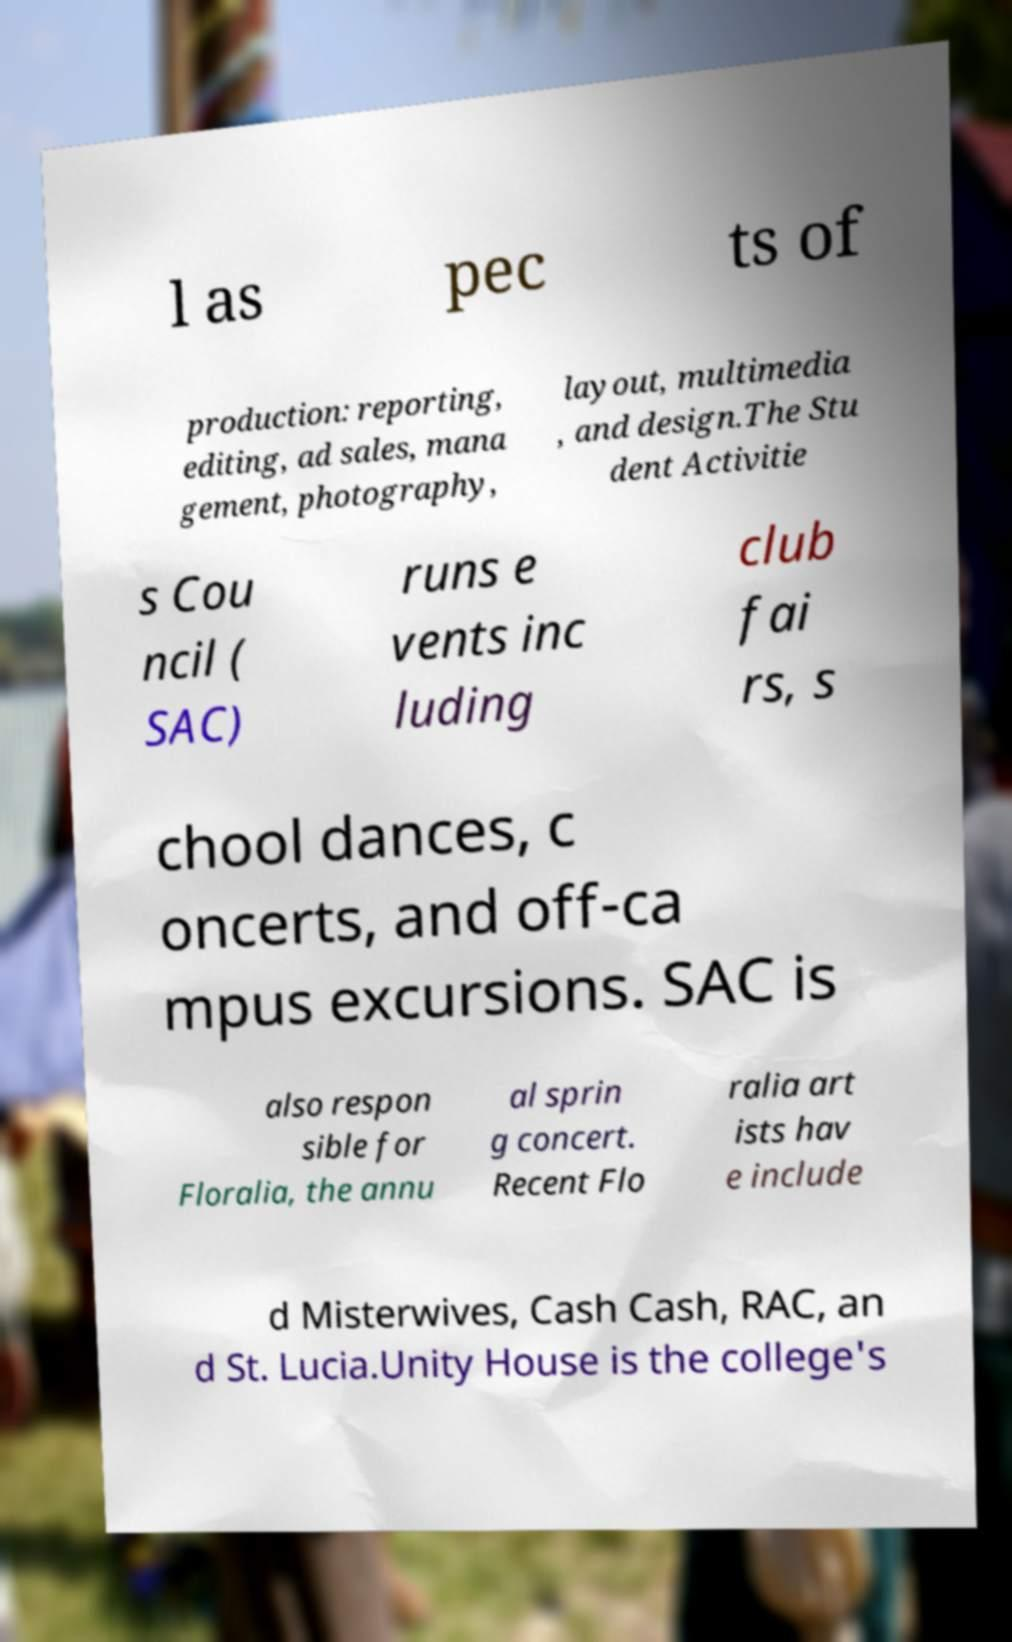Please identify and transcribe the text found in this image. l as pec ts of production: reporting, editing, ad sales, mana gement, photography, layout, multimedia , and design.The Stu dent Activitie s Cou ncil ( SAC) runs e vents inc luding club fai rs, s chool dances, c oncerts, and off-ca mpus excursions. SAC is also respon sible for Floralia, the annu al sprin g concert. Recent Flo ralia art ists hav e include d Misterwives, Cash Cash, RAC, an d St. Lucia.Unity House is the college's 